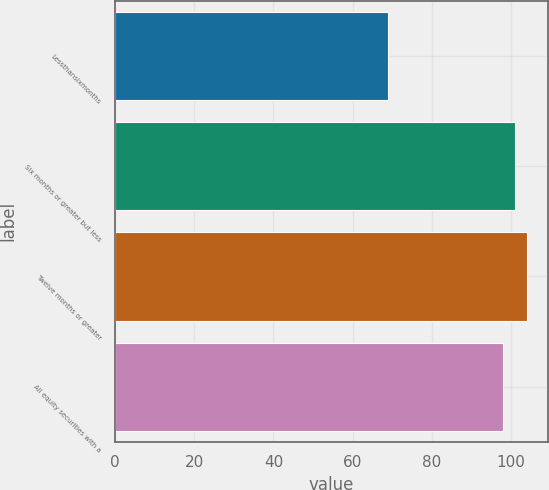Convert chart. <chart><loc_0><loc_0><loc_500><loc_500><bar_chart><fcel>Lessthansixmonths<fcel>Six months or greater but less<fcel>Twelve months or greater<fcel>All equity securities with a<nl><fcel>69<fcel>101.1<fcel>104.2<fcel>98<nl></chart> 